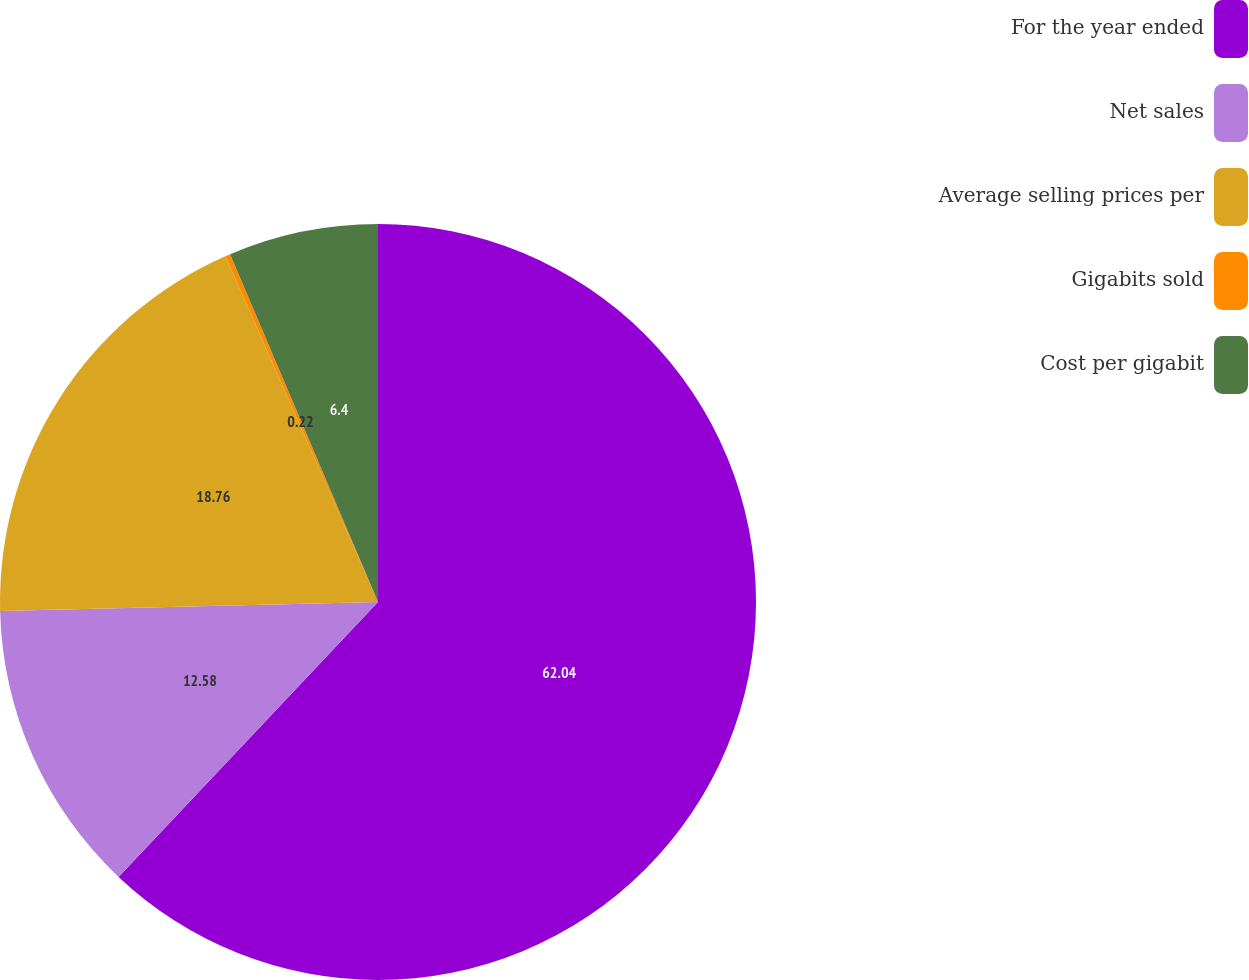<chart> <loc_0><loc_0><loc_500><loc_500><pie_chart><fcel>For the year ended<fcel>Net sales<fcel>Average selling prices per<fcel>Gigabits sold<fcel>Cost per gigabit<nl><fcel>62.04%<fcel>12.58%<fcel>18.76%<fcel>0.22%<fcel>6.4%<nl></chart> 